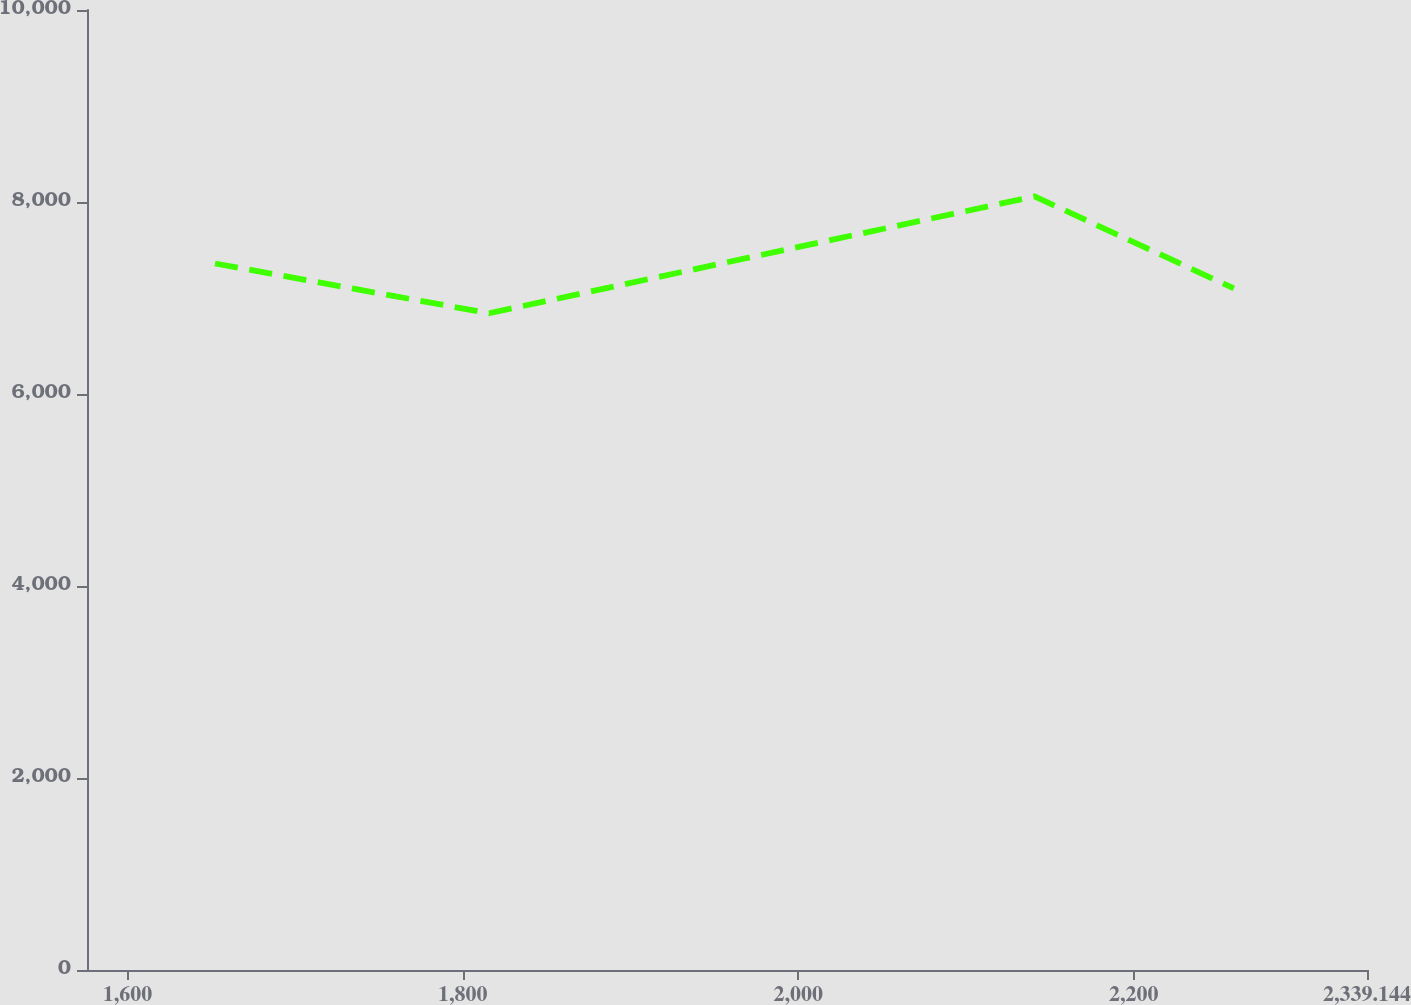Convert chart. <chart><loc_0><loc_0><loc_500><loc_500><line_chart><ecel><fcel>Amount<nl><fcel>1652.21<fcel>7359.37<nl><fcel>1815.61<fcel>6840.79<nl><fcel>2140.92<fcel>8058.51<nl><fcel>2259.75<fcel>7100.08<nl><fcel>2415.47<fcel>5465.59<nl></chart> 